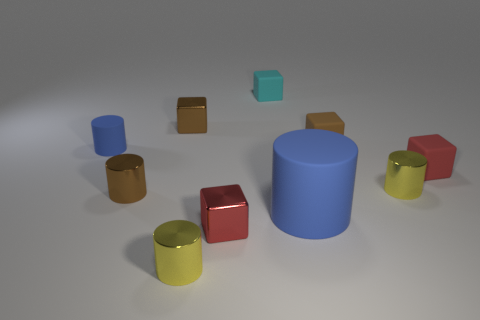What number of cyan things are either small matte blocks or small objects?
Give a very brief answer. 1. What number of things are either brown rubber objects or blue matte things that are right of the small blue cylinder?
Keep it short and to the point. 2. What is the material of the small yellow object that is on the right side of the tiny cyan cube?
Offer a very short reply. Metal. There is a red metal thing that is the same size as the brown cylinder; what is its shape?
Keep it short and to the point. Cube. Is there another small thing that has the same shape as the small red rubber thing?
Your answer should be very brief. Yes. Do the cyan thing and the small brown block that is in front of the brown metallic block have the same material?
Give a very brief answer. Yes. The brown cube that is on the left side of the small thing that is in front of the red shiny object is made of what material?
Keep it short and to the point. Metal. Are there more red things behind the tiny cyan matte object than gray metallic spheres?
Give a very brief answer. No. Are any small metal things visible?
Make the answer very short. Yes. There is a cylinder that is right of the big blue matte object; what is its color?
Your answer should be very brief. Yellow. 